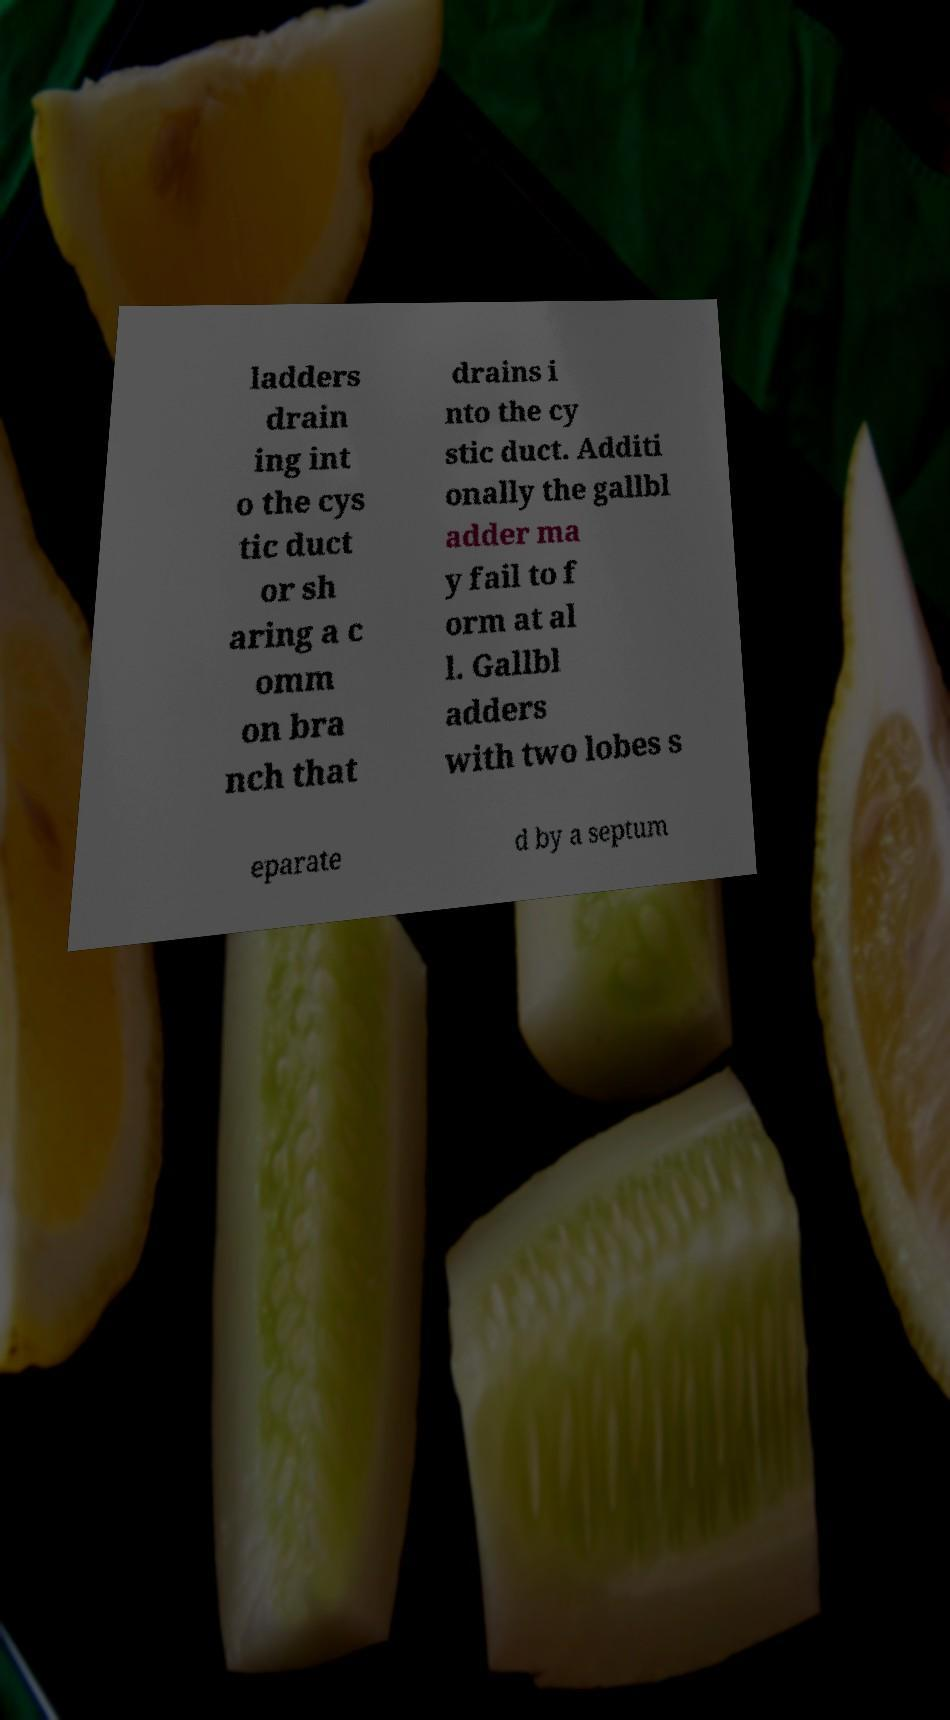Please identify and transcribe the text found in this image. ladders drain ing int o the cys tic duct or sh aring a c omm on bra nch that drains i nto the cy stic duct. Additi onally the gallbl adder ma y fail to f orm at al l. Gallbl adders with two lobes s eparate d by a septum 